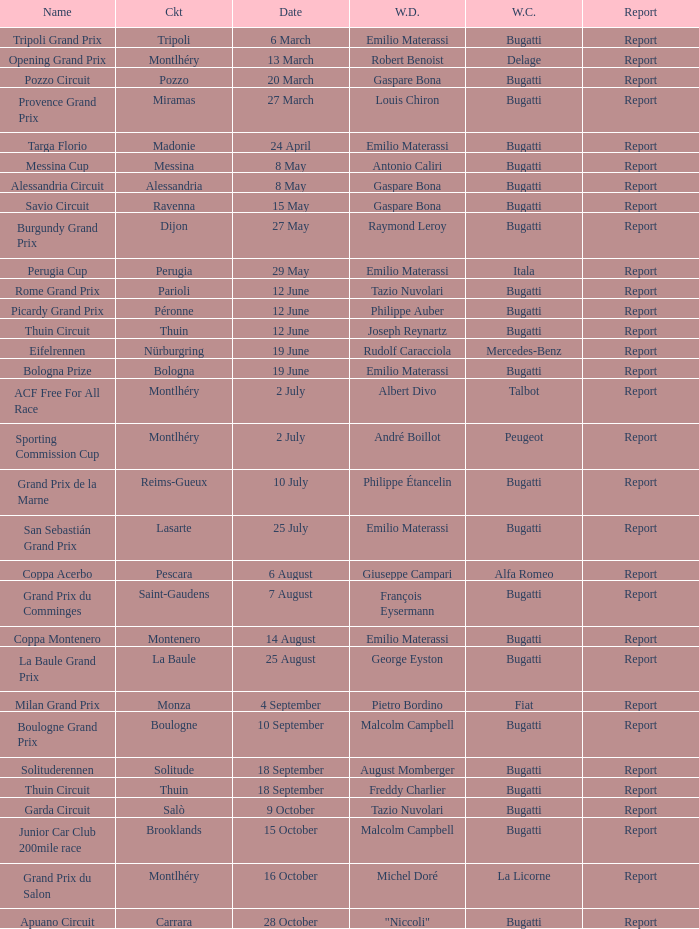When did Gaspare Bona win the Pozzo Circuit? 20 March. 